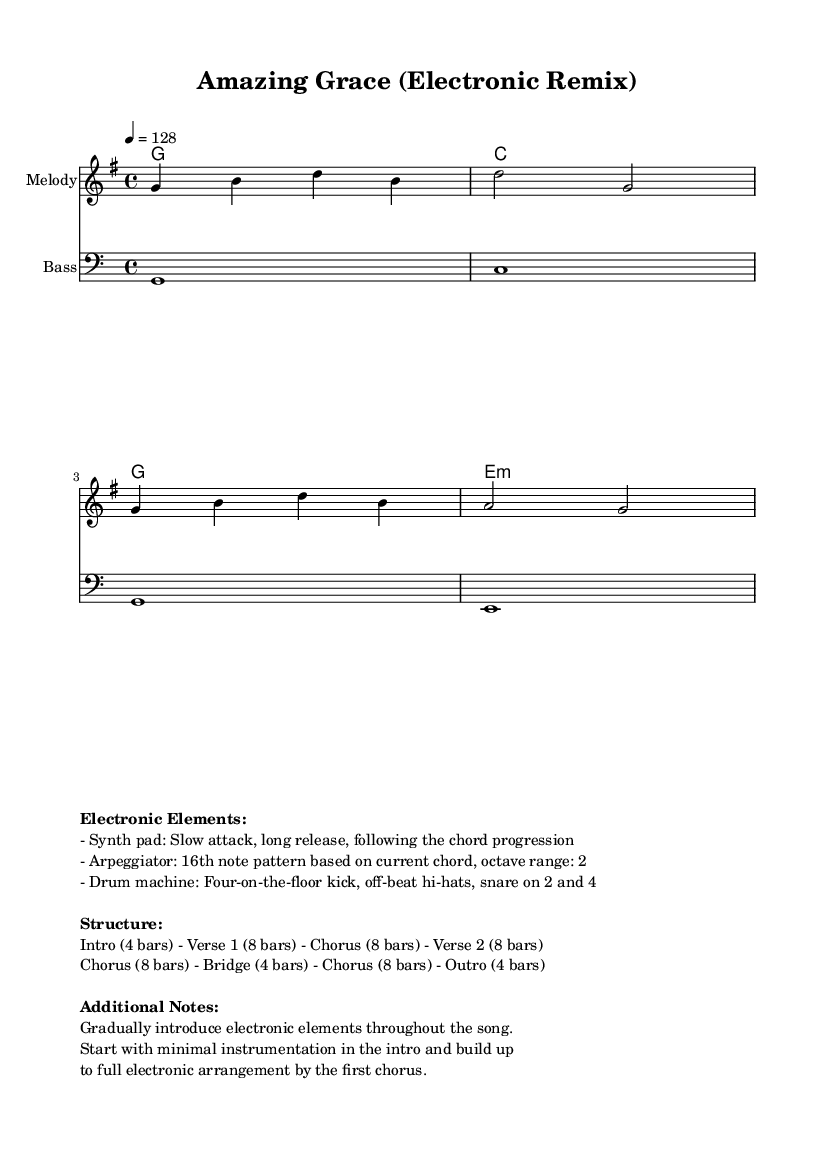What is the key signature of this music? The key signature is G major, which contains one sharp (F#). This can be identified by looking for sharps or flats indicated at the beginning of the staff.
Answer: G major What is the time signature of this music? The time signature is 4/4, which means there are four beats in each measure. This can be observed from the notation indicated right after the key signature.
Answer: 4/4 What is the tempo marking for this piece? The tempo marking is quarter note equals 128 beats per minute. This is found at the beginning of the piece, specifying the speed of the music.
Answer: 128 How many bars are in the chorus section? The chorus section consists of 8 bars, as specified in the structure notes. Counting the bars written for the chorus section of the score confirms this count.
Answer: 8 bars Which electronic element is introduced gradually throughout the song? The electronic elements introduced gradually include the synthetic pad, which has a slow attack and a long release; this is mentioned in the additional notes.
Answer: Synth pad What type of rhythm does the drum machine use? The drum machine uses a four-on-the-floor kick pattern, combined with off-beat hi-hats and a snare on beats 2 and 4, indicated in the description of electronic elements.
Answer: Four-on-the-floor What is the instrument used for the melody in the score? The melody is played on a staff designated for "Melody," as noted in the score layout. This indicates that a specific instrument is playing the melody line.
Answer: Melody 